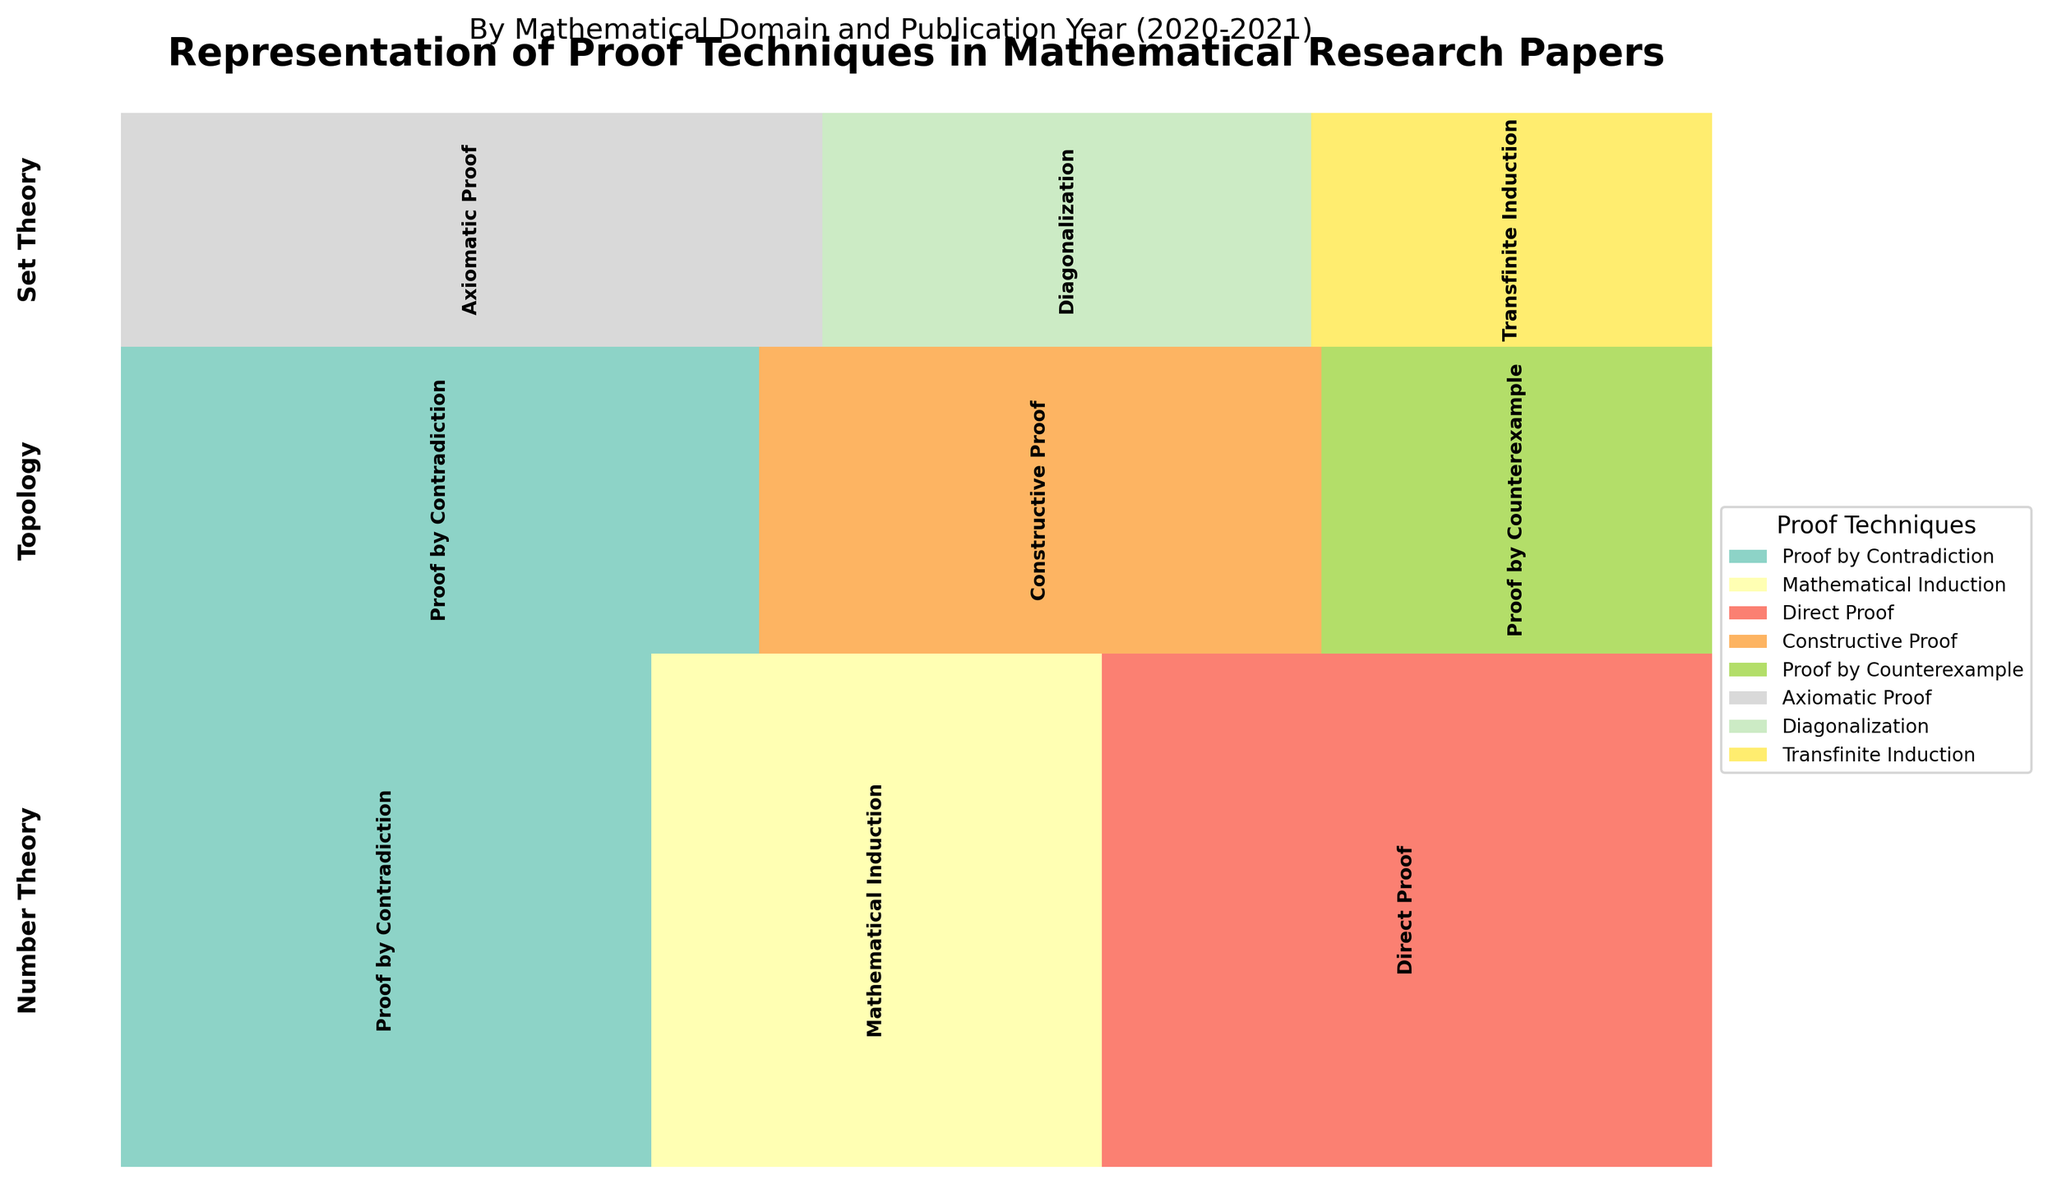What is the title of the plot? The title of the plot is the main heading that describes the overall theme and focus of the figure. It is usually placed at the top of the plot.
Answer: Representation of Proof Techniques in Mathematical Research Papers Which Mathematical Domain has the smallest representation in 2020? To determine which Mathematical Domain has the smallest representation, we look at the vertical sections of the plot corresponding to the year 2020 and compare their heights. The smallest section represents the domain with the least representation.
Answer: Set Theory What proof technique is most frequently used in the Number Theory domain for the year 2021? Identify the part of the plot that corresponds to Number Theory in 2021 and then locate the segment with the largest width within that section.
Answer: Direct Proof Which domain shows an increase in usage of Proof by Contradiction from 2020 to 2021? Compare the heights of the Proof by Contradiction segments for each domain from 2020 to 2021. Identify the domain where the height has increased.
Answer: Number Theory Among Topology proofs, which technique is used less frequently in 2021 compared to 2020? Compare the widths of the segments for each proof technique in the Topology domain between 2020 and 2021. Identify the technique with a reduced width in 2021.
Answer: Proof by Counterexample How does the representation of Constructive Proof in Topology compare to Transfinite Induction in Set Theory for the year 2021? Compare the widths of the segments for Constructive Proof in Topology and Transfinite Induction in Set Theory in the year 2021. Determine if one is greater than the other.
Answer: Constructive Proof in Topology is greater than Transfinite Induction in Set Theory Which Mathematical Domain has the most diverse set of proof techniques used across both years? Look at each domain's section and count the distinct proof techniques used, considering both years. The domain with the highest count of different techniques is the most diverse.
Answer: Number Theory 